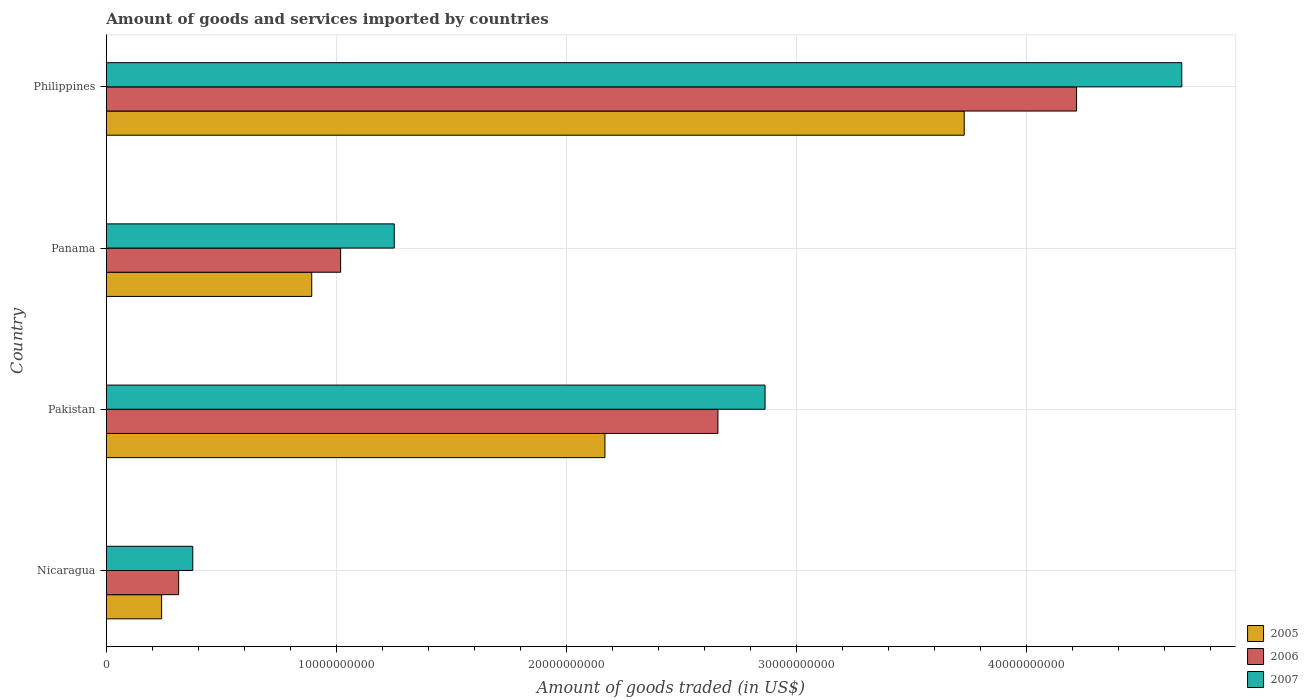Are the number of bars per tick equal to the number of legend labels?
Your response must be concise. Yes. In how many cases, is the number of bars for a given country not equal to the number of legend labels?
Provide a short and direct response. 0. What is the total amount of goods and services imported in 2006 in Panama?
Provide a short and direct response. 1.02e+1. Across all countries, what is the maximum total amount of goods and services imported in 2005?
Make the answer very short. 3.73e+1. Across all countries, what is the minimum total amount of goods and services imported in 2005?
Your answer should be compact. 2.40e+09. In which country was the total amount of goods and services imported in 2007 minimum?
Keep it short and to the point. Nicaragua. What is the total total amount of goods and services imported in 2005 in the graph?
Keep it short and to the point. 7.03e+1. What is the difference between the total amount of goods and services imported in 2007 in Pakistan and that in Panama?
Ensure brevity in your answer.  1.61e+1. What is the difference between the total amount of goods and services imported in 2006 in Panama and the total amount of goods and services imported in 2007 in Pakistan?
Your answer should be very brief. -1.85e+1. What is the average total amount of goods and services imported in 2006 per country?
Provide a succinct answer. 2.05e+1. What is the difference between the total amount of goods and services imported in 2006 and total amount of goods and services imported in 2007 in Panama?
Your answer should be very brief. -2.33e+09. What is the ratio of the total amount of goods and services imported in 2005 in Pakistan to that in Panama?
Offer a very short reply. 2.43. What is the difference between the highest and the second highest total amount of goods and services imported in 2006?
Provide a succinct answer. 1.56e+1. What is the difference between the highest and the lowest total amount of goods and services imported in 2007?
Offer a terse response. 4.30e+1. In how many countries, is the total amount of goods and services imported in 2007 greater than the average total amount of goods and services imported in 2007 taken over all countries?
Keep it short and to the point. 2. Is the sum of the total amount of goods and services imported in 2005 in Nicaragua and Philippines greater than the maximum total amount of goods and services imported in 2006 across all countries?
Your response must be concise. No. What does the 2nd bar from the bottom in Nicaragua represents?
Provide a succinct answer. 2006. How many countries are there in the graph?
Offer a terse response. 4. What is the difference between two consecutive major ticks on the X-axis?
Your answer should be compact. 1.00e+1. Are the values on the major ticks of X-axis written in scientific E-notation?
Your answer should be very brief. No. What is the title of the graph?
Your response must be concise. Amount of goods and services imported by countries. What is the label or title of the X-axis?
Your response must be concise. Amount of goods traded (in US$). What is the Amount of goods traded (in US$) of 2005 in Nicaragua?
Keep it short and to the point. 2.40e+09. What is the Amount of goods traded (in US$) in 2006 in Nicaragua?
Offer a very short reply. 3.14e+09. What is the Amount of goods traded (in US$) of 2007 in Nicaragua?
Offer a terse response. 3.76e+09. What is the Amount of goods traded (in US$) in 2005 in Pakistan?
Your response must be concise. 2.17e+1. What is the Amount of goods traded (in US$) of 2006 in Pakistan?
Make the answer very short. 2.66e+1. What is the Amount of goods traded (in US$) in 2007 in Pakistan?
Your answer should be very brief. 2.86e+1. What is the Amount of goods traded (in US$) of 2005 in Panama?
Provide a succinct answer. 8.93e+09. What is the Amount of goods traded (in US$) of 2006 in Panama?
Your answer should be very brief. 1.02e+1. What is the Amount of goods traded (in US$) in 2007 in Panama?
Make the answer very short. 1.25e+1. What is the Amount of goods traded (in US$) in 2005 in Philippines?
Provide a succinct answer. 3.73e+1. What is the Amount of goods traded (in US$) of 2006 in Philippines?
Your response must be concise. 4.22e+1. What is the Amount of goods traded (in US$) of 2007 in Philippines?
Provide a succinct answer. 4.68e+1. Across all countries, what is the maximum Amount of goods traded (in US$) of 2005?
Keep it short and to the point. 3.73e+1. Across all countries, what is the maximum Amount of goods traded (in US$) of 2006?
Ensure brevity in your answer.  4.22e+1. Across all countries, what is the maximum Amount of goods traded (in US$) in 2007?
Offer a very short reply. 4.68e+1. Across all countries, what is the minimum Amount of goods traded (in US$) of 2005?
Ensure brevity in your answer.  2.40e+09. Across all countries, what is the minimum Amount of goods traded (in US$) in 2006?
Ensure brevity in your answer.  3.14e+09. Across all countries, what is the minimum Amount of goods traded (in US$) in 2007?
Your answer should be compact. 3.76e+09. What is the total Amount of goods traded (in US$) in 2005 in the graph?
Give a very brief answer. 7.03e+1. What is the total Amount of goods traded (in US$) in 2006 in the graph?
Your response must be concise. 8.21e+1. What is the total Amount of goods traded (in US$) in 2007 in the graph?
Your answer should be very brief. 9.17e+1. What is the difference between the Amount of goods traded (in US$) of 2005 in Nicaragua and that in Pakistan?
Provide a short and direct response. -1.93e+1. What is the difference between the Amount of goods traded (in US$) of 2006 in Nicaragua and that in Pakistan?
Offer a terse response. -2.35e+1. What is the difference between the Amount of goods traded (in US$) of 2007 in Nicaragua and that in Pakistan?
Ensure brevity in your answer.  -2.49e+1. What is the difference between the Amount of goods traded (in US$) of 2005 in Nicaragua and that in Panama?
Your answer should be very brief. -6.53e+09. What is the difference between the Amount of goods traded (in US$) of 2006 in Nicaragua and that in Panama?
Keep it short and to the point. -7.04e+09. What is the difference between the Amount of goods traded (in US$) in 2007 in Nicaragua and that in Panama?
Give a very brief answer. -8.76e+09. What is the difference between the Amount of goods traded (in US$) of 2005 in Nicaragua and that in Philippines?
Your answer should be compact. -3.49e+1. What is the difference between the Amount of goods traded (in US$) of 2006 in Nicaragua and that in Philippines?
Offer a very short reply. -3.90e+1. What is the difference between the Amount of goods traded (in US$) in 2007 in Nicaragua and that in Philippines?
Offer a very short reply. -4.30e+1. What is the difference between the Amount of goods traded (in US$) of 2005 in Pakistan and that in Panama?
Your response must be concise. 1.28e+1. What is the difference between the Amount of goods traded (in US$) in 2006 in Pakistan and that in Panama?
Offer a very short reply. 1.64e+1. What is the difference between the Amount of goods traded (in US$) of 2007 in Pakistan and that in Panama?
Ensure brevity in your answer.  1.61e+1. What is the difference between the Amount of goods traded (in US$) of 2005 in Pakistan and that in Philippines?
Provide a short and direct response. -1.56e+1. What is the difference between the Amount of goods traded (in US$) in 2006 in Pakistan and that in Philippines?
Offer a terse response. -1.56e+1. What is the difference between the Amount of goods traded (in US$) in 2007 in Pakistan and that in Philippines?
Ensure brevity in your answer.  -1.81e+1. What is the difference between the Amount of goods traded (in US$) of 2005 in Panama and that in Philippines?
Your answer should be compact. -2.84e+1. What is the difference between the Amount of goods traded (in US$) of 2006 in Panama and that in Philippines?
Ensure brevity in your answer.  -3.20e+1. What is the difference between the Amount of goods traded (in US$) in 2007 in Panama and that in Philippines?
Give a very brief answer. -3.42e+1. What is the difference between the Amount of goods traded (in US$) of 2005 in Nicaragua and the Amount of goods traded (in US$) of 2006 in Pakistan?
Give a very brief answer. -2.42e+1. What is the difference between the Amount of goods traded (in US$) of 2005 in Nicaragua and the Amount of goods traded (in US$) of 2007 in Pakistan?
Offer a very short reply. -2.62e+1. What is the difference between the Amount of goods traded (in US$) of 2006 in Nicaragua and the Amount of goods traded (in US$) of 2007 in Pakistan?
Your answer should be very brief. -2.55e+1. What is the difference between the Amount of goods traded (in US$) of 2005 in Nicaragua and the Amount of goods traded (in US$) of 2006 in Panama?
Keep it short and to the point. -7.78e+09. What is the difference between the Amount of goods traded (in US$) of 2005 in Nicaragua and the Amount of goods traded (in US$) of 2007 in Panama?
Give a very brief answer. -1.01e+1. What is the difference between the Amount of goods traded (in US$) of 2006 in Nicaragua and the Amount of goods traded (in US$) of 2007 in Panama?
Offer a terse response. -9.38e+09. What is the difference between the Amount of goods traded (in US$) of 2005 in Nicaragua and the Amount of goods traded (in US$) of 2006 in Philippines?
Offer a very short reply. -3.98e+1. What is the difference between the Amount of goods traded (in US$) in 2005 in Nicaragua and the Amount of goods traded (in US$) in 2007 in Philippines?
Provide a succinct answer. -4.44e+1. What is the difference between the Amount of goods traded (in US$) of 2006 in Nicaragua and the Amount of goods traded (in US$) of 2007 in Philippines?
Your response must be concise. -4.36e+1. What is the difference between the Amount of goods traded (in US$) of 2005 in Pakistan and the Amount of goods traded (in US$) of 2006 in Panama?
Provide a short and direct response. 1.15e+1. What is the difference between the Amount of goods traded (in US$) in 2005 in Pakistan and the Amount of goods traded (in US$) in 2007 in Panama?
Keep it short and to the point. 9.16e+09. What is the difference between the Amount of goods traded (in US$) of 2006 in Pakistan and the Amount of goods traded (in US$) of 2007 in Panama?
Give a very brief answer. 1.41e+1. What is the difference between the Amount of goods traded (in US$) of 2005 in Pakistan and the Amount of goods traded (in US$) of 2006 in Philippines?
Your response must be concise. -2.05e+1. What is the difference between the Amount of goods traded (in US$) of 2005 in Pakistan and the Amount of goods traded (in US$) of 2007 in Philippines?
Make the answer very short. -2.51e+1. What is the difference between the Amount of goods traded (in US$) of 2006 in Pakistan and the Amount of goods traded (in US$) of 2007 in Philippines?
Offer a very short reply. -2.02e+1. What is the difference between the Amount of goods traded (in US$) in 2005 in Panama and the Amount of goods traded (in US$) in 2006 in Philippines?
Your answer should be very brief. -3.33e+1. What is the difference between the Amount of goods traded (in US$) in 2005 in Panama and the Amount of goods traded (in US$) in 2007 in Philippines?
Your answer should be compact. -3.78e+1. What is the difference between the Amount of goods traded (in US$) in 2006 in Panama and the Amount of goods traded (in US$) in 2007 in Philippines?
Your answer should be very brief. -3.66e+1. What is the average Amount of goods traded (in US$) in 2005 per country?
Offer a terse response. 1.76e+1. What is the average Amount of goods traded (in US$) of 2006 per country?
Keep it short and to the point. 2.05e+1. What is the average Amount of goods traded (in US$) in 2007 per country?
Provide a succinct answer. 2.29e+1. What is the difference between the Amount of goods traded (in US$) in 2005 and Amount of goods traded (in US$) in 2006 in Nicaragua?
Offer a very short reply. -7.40e+08. What is the difference between the Amount of goods traded (in US$) of 2005 and Amount of goods traded (in US$) of 2007 in Nicaragua?
Offer a very short reply. -1.35e+09. What is the difference between the Amount of goods traded (in US$) of 2006 and Amount of goods traded (in US$) of 2007 in Nicaragua?
Offer a terse response. -6.14e+08. What is the difference between the Amount of goods traded (in US$) in 2005 and Amount of goods traded (in US$) in 2006 in Pakistan?
Offer a very short reply. -4.91e+09. What is the difference between the Amount of goods traded (in US$) of 2005 and Amount of goods traded (in US$) of 2007 in Pakistan?
Make the answer very short. -6.96e+09. What is the difference between the Amount of goods traded (in US$) in 2006 and Amount of goods traded (in US$) in 2007 in Pakistan?
Give a very brief answer. -2.05e+09. What is the difference between the Amount of goods traded (in US$) in 2005 and Amount of goods traded (in US$) in 2006 in Panama?
Provide a succinct answer. -1.26e+09. What is the difference between the Amount of goods traded (in US$) of 2005 and Amount of goods traded (in US$) of 2007 in Panama?
Your answer should be very brief. -3.59e+09. What is the difference between the Amount of goods traded (in US$) in 2006 and Amount of goods traded (in US$) in 2007 in Panama?
Ensure brevity in your answer.  -2.33e+09. What is the difference between the Amount of goods traded (in US$) of 2005 and Amount of goods traded (in US$) of 2006 in Philippines?
Make the answer very short. -4.89e+09. What is the difference between the Amount of goods traded (in US$) of 2005 and Amount of goods traded (in US$) of 2007 in Philippines?
Offer a very short reply. -9.46e+09. What is the difference between the Amount of goods traded (in US$) of 2006 and Amount of goods traded (in US$) of 2007 in Philippines?
Ensure brevity in your answer.  -4.58e+09. What is the ratio of the Amount of goods traded (in US$) in 2005 in Nicaragua to that in Pakistan?
Keep it short and to the point. 0.11. What is the ratio of the Amount of goods traded (in US$) of 2006 in Nicaragua to that in Pakistan?
Your answer should be very brief. 0.12. What is the ratio of the Amount of goods traded (in US$) in 2007 in Nicaragua to that in Pakistan?
Provide a succinct answer. 0.13. What is the ratio of the Amount of goods traded (in US$) in 2005 in Nicaragua to that in Panama?
Make the answer very short. 0.27. What is the ratio of the Amount of goods traded (in US$) of 2006 in Nicaragua to that in Panama?
Ensure brevity in your answer.  0.31. What is the ratio of the Amount of goods traded (in US$) of 2007 in Nicaragua to that in Panama?
Give a very brief answer. 0.3. What is the ratio of the Amount of goods traded (in US$) of 2005 in Nicaragua to that in Philippines?
Ensure brevity in your answer.  0.06. What is the ratio of the Amount of goods traded (in US$) of 2006 in Nicaragua to that in Philippines?
Provide a succinct answer. 0.07. What is the ratio of the Amount of goods traded (in US$) of 2007 in Nicaragua to that in Philippines?
Provide a short and direct response. 0.08. What is the ratio of the Amount of goods traded (in US$) of 2005 in Pakistan to that in Panama?
Your answer should be compact. 2.43. What is the ratio of the Amount of goods traded (in US$) of 2006 in Pakistan to that in Panama?
Your answer should be compact. 2.61. What is the ratio of the Amount of goods traded (in US$) of 2007 in Pakistan to that in Panama?
Your answer should be compact. 2.29. What is the ratio of the Amount of goods traded (in US$) of 2005 in Pakistan to that in Philippines?
Your answer should be compact. 0.58. What is the ratio of the Amount of goods traded (in US$) of 2006 in Pakistan to that in Philippines?
Offer a very short reply. 0.63. What is the ratio of the Amount of goods traded (in US$) in 2007 in Pakistan to that in Philippines?
Provide a short and direct response. 0.61. What is the ratio of the Amount of goods traded (in US$) of 2005 in Panama to that in Philippines?
Offer a very short reply. 0.24. What is the ratio of the Amount of goods traded (in US$) in 2006 in Panama to that in Philippines?
Your answer should be very brief. 0.24. What is the ratio of the Amount of goods traded (in US$) of 2007 in Panama to that in Philippines?
Provide a succinct answer. 0.27. What is the difference between the highest and the second highest Amount of goods traded (in US$) in 2005?
Your answer should be very brief. 1.56e+1. What is the difference between the highest and the second highest Amount of goods traded (in US$) of 2006?
Provide a short and direct response. 1.56e+1. What is the difference between the highest and the second highest Amount of goods traded (in US$) in 2007?
Ensure brevity in your answer.  1.81e+1. What is the difference between the highest and the lowest Amount of goods traded (in US$) in 2005?
Ensure brevity in your answer.  3.49e+1. What is the difference between the highest and the lowest Amount of goods traded (in US$) in 2006?
Your answer should be very brief. 3.90e+1. What is the difference between the highest and the lowest Amount of goods traded (in US$) of 2007?
Give a very brief answer. 4.30e+1. 